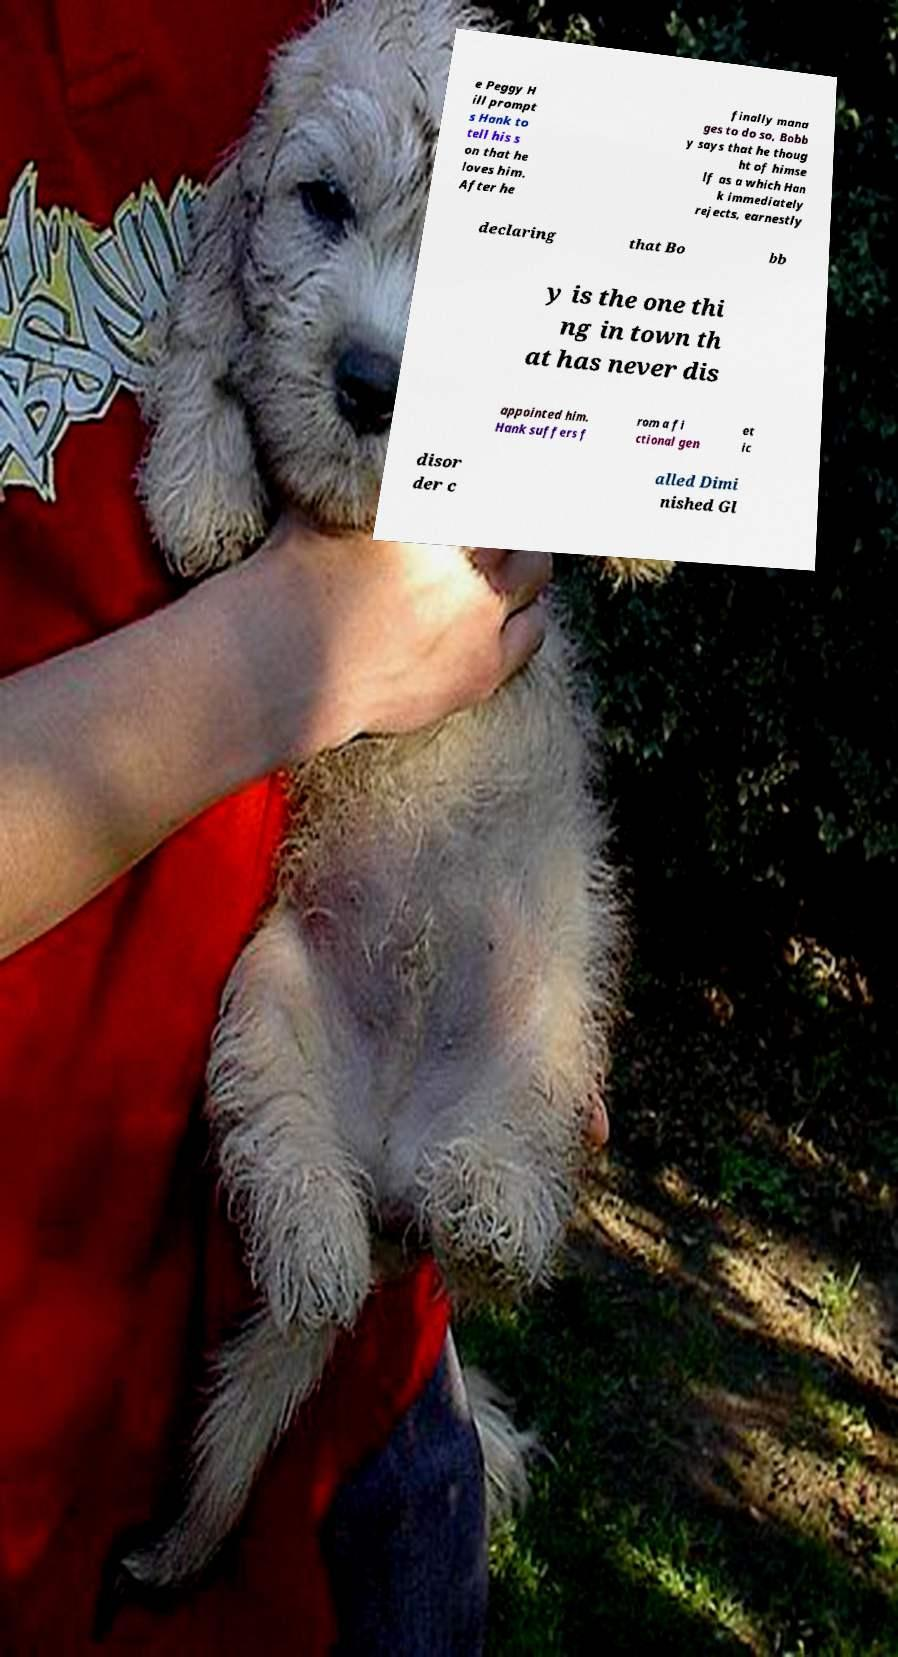Can you accurately transcribe the text from the provided image for me? e Peggy H ill prompt s Hank to tell his s on that he loves him. After he finally mana ges to do so, Bobb y says that he thoug ht of himse lf as a which Han k immediately rejects, earnestly declaring that Bo bb y is the one thi ng in town th at has never dis appointed him. Hank suffers f rom a fi ctional gen et ic disor der c alled Dimi nished Gl 